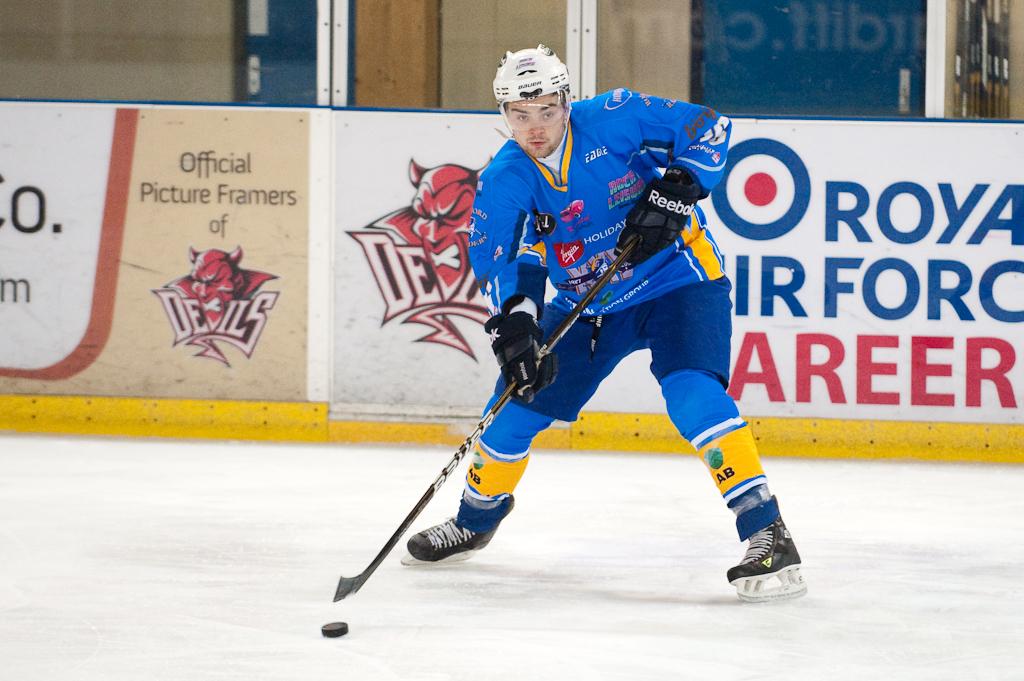What is the ad in the back for?
Your answer should be compact. Royal air force. 